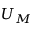Convert formula to latex. <formula><loc_0><loc_0><loc_500><loc_500>U _ { M }</formula> 